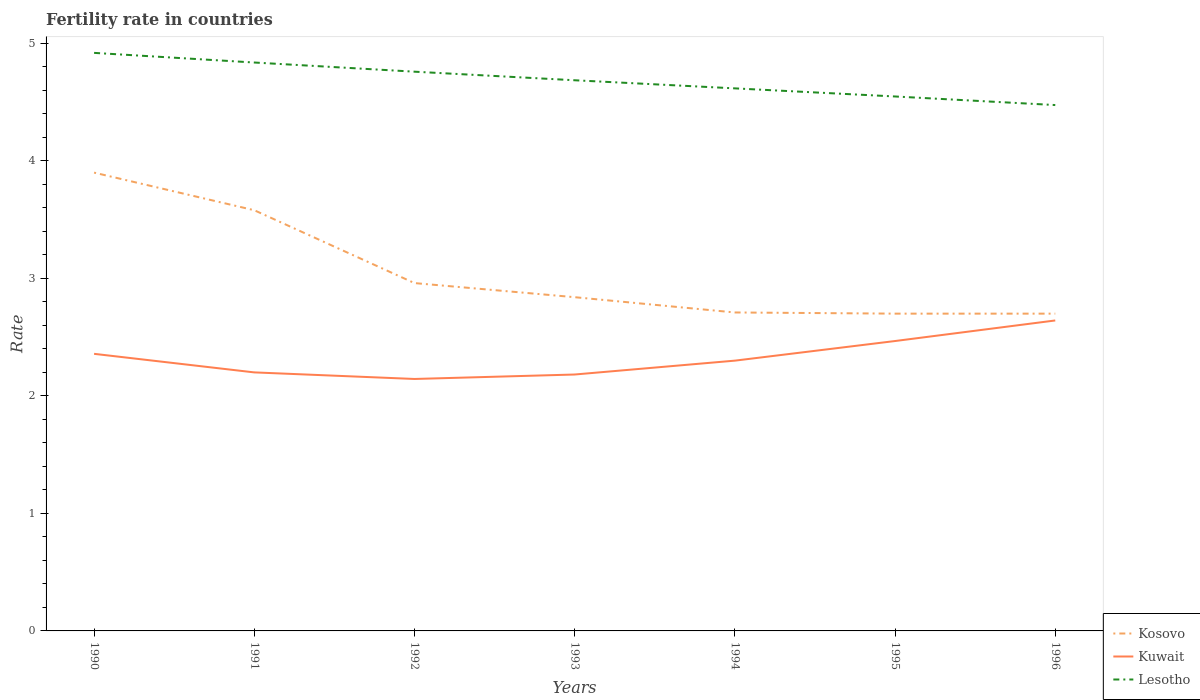How many different coloured lines are there?
Make the answer very short. 3. Does the line corresponding to Kuwait intersect with the line corresponding to Kosovo?
Give a very brief answer. No. Across all years, what is the maximum fertility rate in Kuwait?
Make the answer very short. 2.14. What is the total fertility rate in Kuwait in the graph?
Offer a very short reply. 0.06. What is the difference between the highest and the second highest fertility rate in Lesotho?
Offer a very short reply. 0.44. What is the difference between the highest and the lowest fertility rate in Kuwait?
Give a very brief answer. 3. What is the difference between two consecutive major ticks on the Y-axis?
Provide a short and direct response. 1. Are the values on the major ticks of Y-axis written in scientific E-notation?
Provide a short and direct response. No. Does the graph contain any zero values?
Keep it short and to the point. No. Where does the legend appear in the graph?
Offer a very short reply. Bottom right. How are the legend labels stacked?
Offer a very short reply. Vertical. What is the title of the graph?
Give a very brief answer. Fertility rate in countries. What is the label or title of the Y-axis?
Provide a succinct answer. Rate. What is the Rate of Kosovo in 1990?
Your response must be concise. 3.9. What is the Rate of Kuwait in 1990?
Your response must be concise. 2.36. What is the Rate in Lesotho in 1990?
Make the answer very short. 4.92. What is the Rate of Kosovo in 1991?
Make the answer very short. 3.58. What is the Rate of Lesotho in 1991?
Ensure brevity in your answer.  4.84. What is the Rate of Kosovo in 1992?
Your answer should be compact. 2.96. What is the Rate in Kuwait in 1992?
Keep it short and to the point. 2.14. What is the Rate of Lesotho in 1992?
Give a very brief answer. 4.76. What is the Rate in Kosovo in 1993?
Ensure brevity in your answer.  2.84. What is the Rate in Kuwait in 1993?
Provide a short and direct response. 2.18. What is the Rate in Lesotho in 1993?
Ensure brevity in your answer.  4.69. What is the Rate of Kosovo in 1994?
Ensure brevity in your answer.  2.71. What is the Rate of Lesotho in 1994?
Offer a very short reply. 4.62. What is the Rate of Kosovo in 1995?
Provide a succinct answer. 2.7. What is the Rate of Kuwait in 1995?
Your response must be concise. 2.47. What is the Rate of Lesotho in 1995?
Your answer should be compact. 4.55. What is the Rate of Kosovo in 1996?
Give a very brief answer. 2.7. What is the Rate of Kuwait in 1996?
Offer a terse response. 2.64. What is the Rate in Lesotho in 1996?
Keep it short and to the point. 4.47. Across all years, what is the maximum Rate of Kuwait?
Make the answer very short. 2.64. Across all years, what is the maximum Rate in Lesotho?
Your answer should be very brief. 4.92. Across all years, what is the minimum Rate in Kuwait?
Offer a very short reply. 2.14. Across all years, what is the minimum Rate of Lesotho?
Your answer should be compact. 4.47. What is the total Rate in Kosovo in the graph?
Offer a terse response. 21.39. What is the total Rate of Kuwait in the graph?
Make the answer very short. 16.29. What is the total Rate of Lesotho in the graph?
Offer a terse response. 32.84. What is the difference between the Rate of Kosovo in 1990 and that in 1991?
Make the answer very short. 0.32. What is the difference between the Rate of Kuwait in 1990 and that in 1991?
Provide a short and direct response. 0.16. What is the difference between the Rate of Lesotho in 1990 and that in 1991?
Your response must be concise. 0.08. What is the difference between the Rate in Kosovo in 1990 and that in 1992?
Give a very brief answer. 0.94. What is the difference between the Rate of Kuwait in 1990 and that in 1992?
Your answer should be compact. 0.21. What is the difference between the Rate of Lesotho in 1990 and that in 1992?
Your answer should be very brief. 0.16. What is the difference between the Rate in Kosovo in 1990 and that in 1993?
Your response must be concise. 1.06. What is the difference between the Rate in Kuwait in 1990 and that in 1993?
Your answer should be very brief. 0.18. What is the difference between the Rate of Lesotho in 1990 and that in 1993?
Make the answer very short. 0.23. What is the difference between the Rate of Kosovo in 1990 and that in 1994?
Provide a succinct answer. 1.19. What is the difference between the Rate of Kuwait in 1990 and that in 1994?
Ensure brevity in your answer.  0.06. What is the difference between the Rate in Lesotho in 1990 and that in 1994?
Provide a succinct answer. 0.3. What is the difference between the Rate of Kosovo in 1990 and that in 1995?
Offer a terse response. 1.2. What is the difference between the Rate in Kuwait in 1990 and that in 1995?
Give a very brief answer. -0.11. What is the difference between the Rate of Lesotho in 1990 and that in 1995?
Provide a succinct answer. 0.37. What is the difference between the Rate in Kuwait in 1990 and that in 1996?
Offer a terse response. -0.28. What is the difference between the Rate in Lesotho in 1990 and that in 1996?
Give a very brief answer. 0.44. What is the difference between the Rate of Kosovo in 1991 and that in 1992?
Give a very brief answer. 0.62. What is the difference between the Rate in Kuwait in 1991 and that in 1992?
Your response must be concise. 0.06. What is the difference between the Rate in Lesotho in 1991 and that in 1992?
Ensure brevity in your answer.  0.08. What is the difference between the Rate of Kosovo in 1991 and that in 1993?
Provide a short and direct response. 0.74. What is the difference between the Rate in Kuwait in 1991 and that in 1993?
Offer a very short reply. 0.02. What is the difference between the Rate of Lesotho in 1991 and that in 1993?
Your answer should be very brief. 0.15. What is the difference between the Rate in Kosovo in 1991 and that in 1994?
Your response must be concise. 0.87. What is the difference between the Rate of Lesotho in 1991 and that in 1994?
Ensure brevity in your answer.  0.22. What is the difference between the Rate of Kosovo in 1991 and that in 1995?
Offer a terse response. 0.88. What is the difference between the Rate of Kuwait in 1991 and that in 1995?
Give a very brief answer. -0.27. What is the difference between the Rate in Lesotho in 1991 and that in 1995?
Ensure brevity in your answer.  0.29. What is the difference between the Rate in Kuwait in 1991 and that in 1996?
Provide a short and direct response. -0.44. What is the difference between the Rate in Lesotho in 1991 and that in 1996?
Your response must be concise. 0.36. What is the difference between the Rate in Kosovo in 1992 and that in 1993?
Provide a succinct answer. 0.12. What is the difference between the Rate in Kuwait in 1992 and that in 1993?
Give a very brief answer. -0.04. What is the difference between the Rate of Lesotho in 1992 and that in 1993?
Offer a very short reply. 0.07. What is the difference between the Rate of Kuwait in 1992 and that in 1994?
Provide a short and direct response. -0.16. What is the difference between the Rate in Lesotho in 1992 and that in 1994?
Keep it short and to the point. 0.14. What is the difference between the Rate in Kosovo in 1992 and that in 1995?
Your answer should be very brief. 0.26. What is the difference between the Rate in Kuwait in 1992 and that in 1995?
Provide a succinct answer. -0.32. What is the difference between the Rate of Lesotho in 1992 and that in 1995?
Your answer should be very brief. 0.21. What is the difference between the Rate in Kosovo in 1992 and that in 1996?
Your answer should be compact. 0.26. What is the difference between the Rate in Kuwait in 1992 and that in 1996?
Provide a succinct answer. -0.5. What is the difference between the Rate in Lesotho in 1992 and that in 1996?
Your response must be concise. 0.28. What is the difference between the Rate of Kosovo in 1993 and that in 1994?
Your answer should be compact. 0.13. What is the difference between the Rate in Kuwait in 1993 and that in 1994?
Provide a short and direct response. -0.12. What is the difference between the Rate of Lesotho in 1993 and that in 1994?
Keep it short and to the point. 0.07. What is the difference between the Rate of Kosovo in 1993 and that in 1995?
Give a very brief answer. 0.14. What is the difference between the Rate of Kuwait in 1993 and that in 1995?
Make the answer very short. -0.28. What is the difference between the Rate in Lesotho in 1993 and that in 1995?
Make the answer very short. 0.14. What is the difference between the Rate of Kosovo in 1993 and that in 1996?
Ensure brevity in your answer.  0.14. What is the difference between the Rate in Kuwait in 1993 and that in 1996?
Keep it short and to the point. -0.46. What is the difference between the Rate of Lesotho in 1993 and that in 1996?
Give a very brief answer. 0.21. What is the difference between the Rate in Kuwait in 1994 and that in 1995?
Provide a succinct answer. -0.17. What is the difference between the Rate of Lesotho in 1994 and that in 1995?
Make the answer very short. 0.07. What is the difference between the Rate of Kuwait in 1994 and that in 1996?
Give a very brief answer. -0.34. What is the difference between the Rate in Lesotho in 1994 and that in 1996?
Give a very brief answer. 0.14. What is the difference between the Rate in Kuwait in 1995 and that in 1996?
Give a very brief answer. -0.17. What is the difference between the Rate in Lesotho in 1995 and that in 1996?
Offer a terse response. 0.07. What is the difference between the Rate of Kosovo in 1990 and the Rate of Kuwait in 1991?
Ensure brevity in your answer.  1.7. What is the difference between the Rate in Kosovo in 1990 and the Rate in Lesotho in 1991?
Your answer should be very brief. -0.94. What is the difference between the Rate of Kuwait in 1990 and the Rate of Lesotho in 1991?
Your response must be concise. -2.48. What is the difference between the Rate of Kosovo in 1990 and the Rate of Kuwait in 1992?
Offer a terse response. 1.76. What is the difference between the Rate of Kosovo in 1990 and the Rate of Lesotho in 1992?
Ensure brevity in your answer.  -0.86. What is the difference between the Rate in Kuwait in 1990 and the Rate in Lesotho in 1992?
Make the answer very short. -2.4. What is the difference between the Rate in Kosovo in 1990 and the Rate in Kuwait in 1993?
Provide a succinct answer. 1.72. What is the difference between the Rate in Kosovo in 1990 and the Rate in Lesotho in 1993?
Offer a terse response. -0.79. What is the difference between the Rate in Kuwait in 1990 and the Rate in Lesotho in 1993?
Keep it short and to the point. -2.33. What is the difference between the Rate of Kosovo in 1990 and the Rate of Kuwait in 1994?
Make the answer very short. 1.6. What is the difference between the Rate in Kosovo in 1990 and the Rate in Lesotho in 1994?
Your answer should be compact. -0.72. What is the difference between the Rate of Kuwait in 1990 and the Rate of Lesotho in 1994?
Provide a short and direct response. -2.26. What is the difference between the Rate in Kosovo in 1990 and the Rate in Kuwait in 1995?
Offer a terse response. 1.43. What is the difference between the Rate of Kosovo in 1990 and the Rate of Lesotho in 1995?
Keep it short and to the point. -0.65. What is the difference between the Rate in Kuwait in 1990 and the Rate in Lesotho in 1995?
Your answer should be compact. -2.19. What is the difference between the Rate in Kosovo in 1990 and the Rate in Kuwait in 1996?
Offer a very short reply. 1.26. What is the difference between the Rate of Kosovo in 1990 and the Rate of Lesotho in 1996?
Your answer should be compact. -0.57. What is the difference between the Rate in Kuwait in 1990 and the Rate in Lesotho in 1996?
Offer a terse response. -2.12. What is the difference between the Rate of Kosovo in 1991 and the Rate of Kuwait in 1992?
Ensure brevity in your answer.  1.44. What is the difference between the Rate in Kosovo in 1991 and the Rate in Lesotho in 1992?
Make the answer very short. -1.18. What is the difference between the Rate in Kuwait in 1991 and the Rate in Lesotho in 1992?
Offer a terse response. -2.56. What is the difference between the Rate in Kosovo in 1991 and the Rate in Kuwait in 1993?
Ensure brevity in your answer.  1.4. What is the difference between the Rate of Kosovo in 1991 and the Rate of Lesotho in 1993?
Your answer should be very brief. -1.11. What is the difference between the Rate in Kuwait in 1991 and the Rate in Lesotho in 1993?
Offer a terse response. -2.49. What is the difference between the Rate of Kosovo in 1991 and the Rate of Kuwait in 1994?
Offer a very short reply. 1.28. What is the difference between the Rate of Kosovo in 1991 and the Rate of Lesotho in 1994?
Keep it short and to the point. -1.04. What is the difference between the Rate in Kuwait in 1991 and the Rate in Lesotho in 1994?
Give a very brief answer. -2.42. What is the difference between the Rate of Kosovo in 1991 and the Rate of Kuwait in 1995?
Keep it short and to the point. 1.11. What is the difference between the Rate of Kosovo in 1991 and the Rate of Lesotho in 1995?
Provide a succinct answer. -0.97. What is the difference between the Rate of Kuwait in 1991 and the Rate of Lesotho in 1995?
Offer a terse response. -2.35. What is the difference between the Rate in Kosovo in 1991 and the Rate in Kuwait in 1996?
Offer a terse response. 0.94. What is the difference between the Rate in Kosovo in 1991 and the Rate in Lesotho in 1996?
Your answer should be very brief. -0.9. What is the difference between the Rate in Kuwait in 1991 and the Rate in Lesotho in 1996?
Provide a succinct answer. -2.27. What is the difference between the Rate of Kosovo in 1992 and the Rate of Kuwait in 1993?
Keep it short and to the point. 0.78. What is the difference between the Rate of Kosovo in 1992 and the Rate of Lesotho in 1993?
Ensure brevity in your answer.  -1.73. What is the difference between the Rate in Kuwait in 1992 and the Rate in Lesotho in 1993?
Make the answer very short. -2.54. What is the difference between the Rate of Kosovo in 1992 and the Rate of Kuwait in 1994?
Offer a very short reply. 0.66. What is the difference between the Rate of Kosovo in 1992 and the Rate of Lesotho in 1994?
Offer a very short reply. -1.66. What is the difference between the Rate of Kuwait in 1992 and the Rate of Lesotho in 1994?
Your answer should be very brief. -2.47. What is the difference between the Rate in Kosovo in 1992 and the Rate in Kuwait in 1995?
Provide a short and direct response. 0.49. What is the difference between the Rate in Kosovo in 1992 and the Rate in Lesotho in 1995?
Make the answer very short. -1.59. What is the difference between the Rate of Kuwait in 1992 and the Rate of Lesotho in 1995?
Provide a succinct answer. -2.4. What is the difference between the Rate of Kosovo in 1992 and the Rate of Kuwait in 1996?
Offer a terse response. 0.32. What is the difference between the Rate in Kosovo in 1992 and the Rate in Lesotho in 1996?
Provide a succinct answer. -1.51. What is the difference between the Rate of Kuwait in 1992 and the Rate of Lesotho in 1996?
Your answer should be very brief. -2.33. What is the difference between the Rate of Kosovo in 1993 and the Rate of Kuwait in 1994?
Give a very brief answer. 0.54. What is the difference between the Rate in Kosovo in 1993 and the Rate in Lesotho in 1994?
Make the answer very short. -1.78. What is the difference between the Rate in Kuwait in 1993 and the Rate in Lesotho in 1994?
Offer a very short reply. -2.44. What is the difference between the Rate in Kosovo in 1993 and the Rate in Kuwait in 1995?
Your answer should be very brief. 0.37. What is the difference between the Rate of Kosovo in 1993 and the Rate of Lesotho in 1995?
Ensure brevity in your answer.  -1.71. What is the difference between the Rate in Kuwait in 1993 and the Rate in Lesotho in 1995?
Your answer should be very brief. -2.37. What is the difference between the Rate in Kosovo in 1993 and the Rate in Kuwait in 1996?
Your response must be concise. 0.2. What is the difference between the Rate of Kosovo in 1993 and the Rate of Lesotho in 1996?
Your answer should be very brief. -1.64. What is the difference between the Rate of Kuwait in 1993 and the Rate of Lesotho in 1996?
Your answer should be compact. -2.29. What is the difference between the Rate of Kosovo in 1994 and the Rate of Kuwait in 1995?
Your answer should be compact. 0.24. What is the difference between the Rate of Kosovo in 1994 and the Rate of Lesotho in 1995?
Your answer should be compact. -1.84. What is the difference between the Rate in Kuwait in 1994 and the Rate in Lesotho in 1995?
Offer a very short reply. -2.25. What is the difference between the Rate of Kosovo in 1994 and the Rate of Kuwait in 1996?
Your response must be concise. 0.07. What is the difference between the Rate in Kosovo in 1994 and the Rate in Lesotho in 1996?
Your answer should be compact. -1.76. What is the difference between the Rate of Kuwait in 1994 and the Rate of Lesotho in 1996?
Make the answer very short. -2.17. What is the difference between the Rate in Kosovo in 1995 and the Rate in Kuwait in 1996?
Provide a short and direct response. 0.06. What is the difference between the Rate of Kosovo in 1995 and the Rate of Lesotho in 1996?
Ensure brevity in your answer.  -1.77. What is the difference between the Rate in Kuwait in 1995 and the Rate in Lesotho in 1996?
Provide a short and direct response. -2.01. What is the average Rate in Kosovo per year?
Provide a succinct answer. 3.06. What is the average Rate in Kuwait per year?
Provide a short and direct response. 2.33. What is the average Rate in Lesotho per year?
Your response must be concise. 4.69. In the year 1990, what is the difference between the Rate of Kosovo and Rate of Kuwait?
Ensure brevity in your answer.  1.54. In the year 1990, what is the difference between the Rate in Kosovo and Rate in Lesotho?
Provide a succinct answer. -1.02. In the year 1990, what is the difference between the Rate of Kuwait and Rate of Lesotho?
Ensure brevity in your answer.  -2.56. In the year 1991, what is the difference between the Rate in Kosovo and Rate in Kuwait?
Offer a very short reply. 1.38. In the year 1991, what is the difference between the Rate of Kosovo and Rate of Lesotho?
Your response must be concise. -1.26. In the year 1991, what is the difference between the Rate in Kuwait and Rate in Lesotho?
Ensure brevity in your answer.  -2.64. In the year 1992, what is the difference between the Rate of Kosovo and Rate of Kuwait?
Provide a short and direct response. 0.82. In the year 1992, what is the difference between the Rate in Kosovo and Rate in Lesotho?
Provide a succinct answer. -1.8. In the year 1992, what is the difference between the Rate in Kuwait and Rate in Lesotho?
Offer a terse response. -2.62. In the year 1993, what is the difference between the Rate in Kosovo and Rate in Kuwait?
Your response must be concise. 0.66. In the year 1993, what is the difference between the Rate in Kosovo and Rate in Lesotho?
Ensure brevity in your answer.  -1.85. In the year 1993, what is the difference between the Rate of Kuwait and Rate of Lesotho?
Give a very brief answer. -2.5. In the year 1994, what is the difference between the Rate of Kosovo and Rate of Kuwait?
Offer a terse response. 0.41. In the year 1994, what is the difference between the Rate in Kosovo and Rate in Lesotho?
Your answer should be compact. -1.91. In the year 1994, what is the difference between the Rate in Kuwait and Rate in Lesotho?
Ensure brevity in your answer.  -2.32. In the year 1995, what is the difference between the Rate of Kosovo and Rate of Kuwait?
Your answer should be very brief. 0.23. In the year 1995, what is the difference between the Rate in Kosovo and Rate in Lesotho?
Your answer should be compact. -1.85. In the year 1995, what is the difference between the Rate in Kuwait and Rate in Lesotho?
Your answer should be very brief. -2.08. In the year 1996, what is the difference between the Rate of Kosovo and Rate of Kuwait?
Your answer should be compact. 0.06. In the year 1996, what is the difference between the Rate in Kosovo and Rate in Lesotho?
Keep it short and to the point. -1.77. In the year 1996, what is the difference between the Rate in Kuwait and Rate in Lesotho?
Keep it short and to the point. -1.83. What is the ratio of the Rate of Kosovo in 1990 to that in 1991?
Ensure brevity in your answer.  1.09. What is the ratio of the Rate of Kuwait in 1990 to that in 1991?
Give a very brief answer. 1.07. What is the ratio of the Rate in Lesotho in 1990 to that in 1991?
Ensure brevity in your answer.  1.02. What is the ratio of the Rate of Kosovo in 1990 to that in 1992?
Ensure brevity in your answer.  1.32. What is the ratio of the Rate of Kuwait in 1990 to that in 1992?
Offer a very short reply. 1.1. What is the ratio of the Rate of Lesotho in 1990 to that in 1992?
Make the answer very short. 1.03. What is the ratio of the Rate in Kosovo in 1990 to that in 1993?
Your answer should be compact. 1.37. What is the ratio of the Rate in Kuwait in 1990 to that in 1993?
Provide a short and direct response. 1.08. What is the ratio of the Rate of Lesotho in 1990 to that in 1993?
Provide a short and direct response. 1.05. What is the ratio of the Rate of Kosovo in 1990 to that in 1994?
Keep it short and to the point. 1.44. What is the ratio of the Rate in Kuwait in 1990 to that in 1994?
Make the answer very short. 1.03. What is the ratio of the Rate of Lesotho in 1990 to that in 1994?
Make the answer very short. 1.07. What is the ratio of the Rate of Kosovo in 1990 to that in 1995?
Provide a succinct answer. 1.44. What is the ratio of the Rate in Kuwait in 1990 to that in 1995?
Your answer should be very brief. 0.96. What is the ratio of the Rate in Lesotho in 1990 to that in 1995?
Provide a short and direct response. 1.08. What is the ratio of the Rate of Kosovo in 1990 to that in 1996?
Your answer should be very brief. 1.44. What is the ratio of the Rate in Kuwait in 1990 to that in 1996?
Your answer should be compact. 0.89. What is the ratio of the Rate of Lesotho in 1990 to that in 1996?
Ensure brevity in your answer.  1.1. What is the ratio of the Rate in Kosovo in 1991 to that in 1992?
Make the answer very short. 1.21. What is the ratio of the Rate in Kuwait in 1991 to that in 1992?
Your answer should be very brief. 1.03. What is the ratio of the Rate of Lesotho in 1991 to that in 1992?
Make the answer very short. 1.02. What is the ratio of the Rate in Kosovo in 1991 to that in 1993?
Your answer should be very brief. 1.26. What is the ratio of the Rate in Kuwait in 1991 to that in 1993?
Ensure brevity in your answer.  1.01. What is the ratio of the Rate in Lesotho in 1991 to that in 1993?
Give a very brief answer. 1.03. What is the ratio of the Rate in Kosovo in 1991 to that in 1994?
Your answer should be compact. 1.32. What is the ratio of the Rate in Kuwait in 1991 to that in 1994?
Offer a terse response. 0.96. What is the ratio of the Rate in Lesotho in 1991 to that in 1994?
Your answer should be compact. 1.05. What is the ratio of the Rate of Kosovo in 1991 to that in 1995?
Offer a very short reply. 1.33. What is the ratio of the Rate of Kuwait in 1991 to that in 1995?
Give a very brief answer. 0.89. What is the ratio of the Rate of Lesotho in 1991 to that in 1995?
Your response must be concise. 1.06. What is the ratio of the Rate of Kosovo in 1991 to that in 1996?
Your answer should be compact. 1.33. What is the ratio of the Rate in Kuwait in 1991 to that in 1996?
Keep it short and to the point. 0.83. What is the ratio of the Rate in Lesotho in 1991 to that in 1996?
Keep it short and to the point. 1.08. What is the ratio of the Rate of Kosovo in 1992 to that in 1993?
Give a very brief answer. 1.04. What is the ratio of the Rate in Kuwait in 1992 to that in 1993?
Your answer should be very brief. 0.98. What is the ratio of the Rate in Lesotho in 1992 to that in 1993?
Keep it short and to the point. 1.02. What is the ratio of the Rate of Kosovo in 1992 to that in 1994?
Keep it short and to the point. 1.09. What is the ratio of the Rate in Kuwait in 1992 to that in 1994?
Ensure brevity in your answer.  0.93. What is the ratio of the Rate of Lesotho in 1992 to that in 1994?
Provide a short and direct response. 1.03. What is the ratio of the Rate of Kosovo in 1992 to that in 1995?
Offer a terse response. 1.1. What is the ratio of the Rate in Kuwait in 1992 to that in 1995?
Your answer should be compact. 0.87. What is the ratio of the Rate in Lesotho in 1992 to that in 1995?
Your answer should be very brief. 1.05. What is the ratio of the Rate of Kosovo in 1992 to that in 1996?
Your answer should be very brief. 1.1. What is the ratio of the Rate in Kuwait in 1992 to that in 1996?
Offer a very short reply. 0.81. What is the ratio of the Rate in Lesotho in 1992 to that in 1996?
Give a very brief answer. 1.06. What is the ratio of the Rate of Kosovo in 1993 to that in 1994?
Offer a very short reply. 1.05. What is the ratio of the Rate in Kuwait in 1993 to that in 1994?
Offer a very short reply. 0.95. What is the ratio of the Rate of Lesotho in 1993 to that in 1994?
Your response must be concise. 1.01. What is the ratio of the Rate of Kosovo in 1993 to that in 1995?
Give a very brief answer. 1.05. What is the ratio of the Rate of Kuwait in 1993 to that in 1995?
Your response must be concise. 0.88. What is the ratio of the Rate of Lesotho in 1993 to that in 1995?
Ensure brevity in your answer.  1.03. What is the ratio of the Rate of Kosovo in 1993 to that in 1996?
Keep it short and to the point. 1.05. What is the ratio of the Rate of Kuwait in 1993 to that in 1996?
Your answer should be very brief. 0.83. What is the ratio of the Rate in Lesotho in 1993 to that in 1996?
Ensure brevity in your answer.  1.05. What is the ratio of the Rate of Kuwait in 1994 to that in 1995?
Offer a terse response. 0.93. What is the ratio of the Rate in Lesotho in 1994 to that in 1995?
Your answer should be compact. 1.02. What is the ratio of the Rate in Kuwait in 1994 to that in 1996?
Provide a short and direct response. 0.87. What is the ratio of the Rate in Lesotho in 1994 to that in 1996?
Your answer should be very brief. 1.03. What is the ratio of the Rate in Kuwait in 1995 to that in 1996?
Provide a short and direct response. 0.93. What is the ratio of the Rate in Lesotho in 1995 to that in 1996?
Make the answer very short. 1.02. What is the difference between the highest and the second highest Rate in Kosovo?
Your answer should be very brief. 0.32. What is the difference between the highest and the second highest Rate in Kuwait?
Provide a succinct answer. 0.17. What is the difference between the highest and the second highest Rate of Lesotho?
Your response must be concise. 0.08. What is the difference between the highest and the lowest Rate in Kosovo?
Keep it short and to the point. 1.2. What is the difference between the highest and the lowest Rate in Kuwait?
Provide a succinct answer. 0.5. What is the difference between the highest and the lowest Rate in Lesotho?
Your response must be concise. 0.44. 